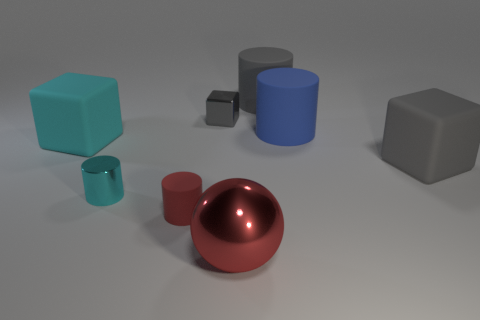Add 1 purple metal cubes. How many objects exist? 9 Subtract all balls. How many objects are left? 7 Add 8 tiny cubes. How many tiny cubes exist? 9 Subtract 0 brown cubes. How many objects are left? 8 Subtract all big blocks. Subtract all blue things. How many objects are left? 5 Add 2 tiny things. How many tiny things are left? 5 